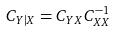<formula> <loc_0><loc_0><loc_500><loc_500>C _ { Y | X } = C _ { Y X } C _ { X X } ^ { - 1 }</formula> 